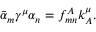Convert formula to latex. <formula><loc_0><loc_0><loc_500><loc_500>\bar { \alpha } _ { m } \gamma ^ { \mu } \alpha _ { n } = f _ { m n } ^ { A } k _ { A } ^ { \mu } .</formula> 